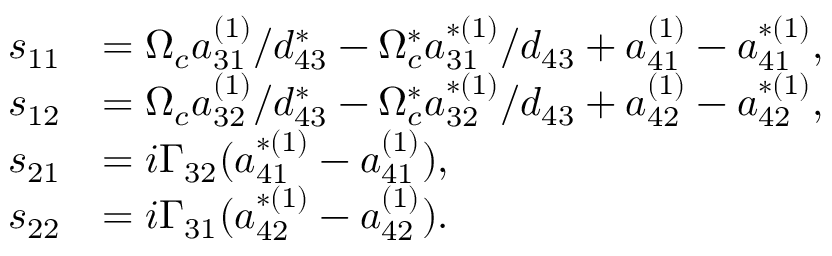Convert formula to latex. <formula><loc_0><loc_0><loc_500><loc_500>\begin{array} { r l } { s _ { 1 1 } } & { = \Omega _ { c } a _ { 3 1 } ^ { ( 1 ) } / d _ { 4 3 } ^ { \ast } - \Omega _ { c } ^ { \ast } a _ { 3 1 } ^ { \ast ( 1 ) } / d _ { 4 3 } + a _ { 4 1 } ^ { ( 1 ) } - a _ { 4 1 } ^ { \ast ( 1 ) } , } \\ { s _ { 1 2 } } & { = \Omega _ { c } a _ { 3 2 } ^ { ( 1 ) } / d _ { 4 3 } ^ { \ast } - \Omega _ { c } ^ { \ast } a _ { 3 2 } ^ { \ast ( 1 ) } / d _ { 4 3 } + a _ { 4 2 } ^ { ( 1 ) } - a _ { 4 2 } ^ { \ast ( 1 ) } , } \\ { s _ { 2 1 } } & { = i \Gamma _ { 3 2 } ( a _ { 4 1 } ^ { \ast ( 1 ) } - a _ { 4 1 } ^ { ( 1 ) } ) , } \\ { s _ { 2 2 } } & { = i \Gamma _ { 3 1 } ( a _ { 4 2 } ^ { \ast ( 1 ) } - a _ { 4 2 } ^ { ( 1 ) } ) . } \end{array}</formula> 